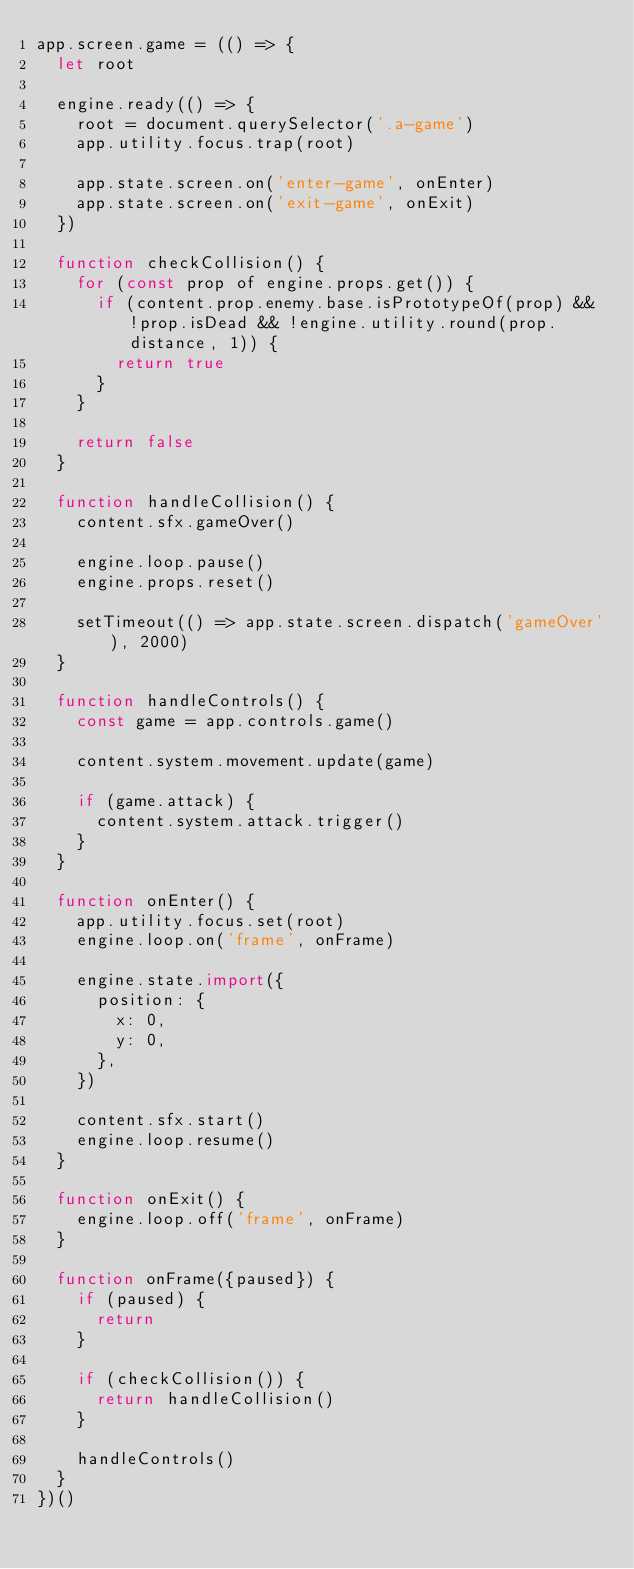<code> <loc_0><loc_0><loc_500><loc_500><_JavaScript_>app.screen.game = (() => {
  let root

  engine.ready(() => {
    root = document.querySelector('.a-game')
    app.utility.focus.trap(root)

    app.state.screen.on('enter-game', onEnter)
    app.state.screen.on('exit-game', onExit)
  })

  function checkCollision() {
    for (const prop of engine.props.get()) {
      if (content.prop.enemy.base.isPrototypeOf(prop) && !prop.isDead && !engine.utility.round(prop.distance, 1)) {
        return true
      }
    }

    return false
  }

  function handleCollision() {
    content.sfx.gameOver()

    engine.loop.pause()
    engine.props.reset()

    setTimeout(() => app.state.screen.dispatch('gameOver'), 2000)
  }

  function handleControls() {
    const game = app.controls.game()

    content.system.movement.update(game)

    if (game.attack) {
      content.system.attack.trigger()
    }
  }

  function onEnter() {
    app.utility.focus.set(root)
    engine.loop.on('frame', onFrame)

    engine.state.import({
      position: {
        x: 0,
        y: 0,
      },
    })

    content.sfx.start()
    engine.loop.resume()
  }

  function onExit() {
    engine.loop.off('frame', onFrame)
  }

  function onFrame({paused}) {
    if (paused) {
      return
    }

    if (checkCollision()) {
      return handleCollision()
    }

    handleControls()
  }
})()
</code> 